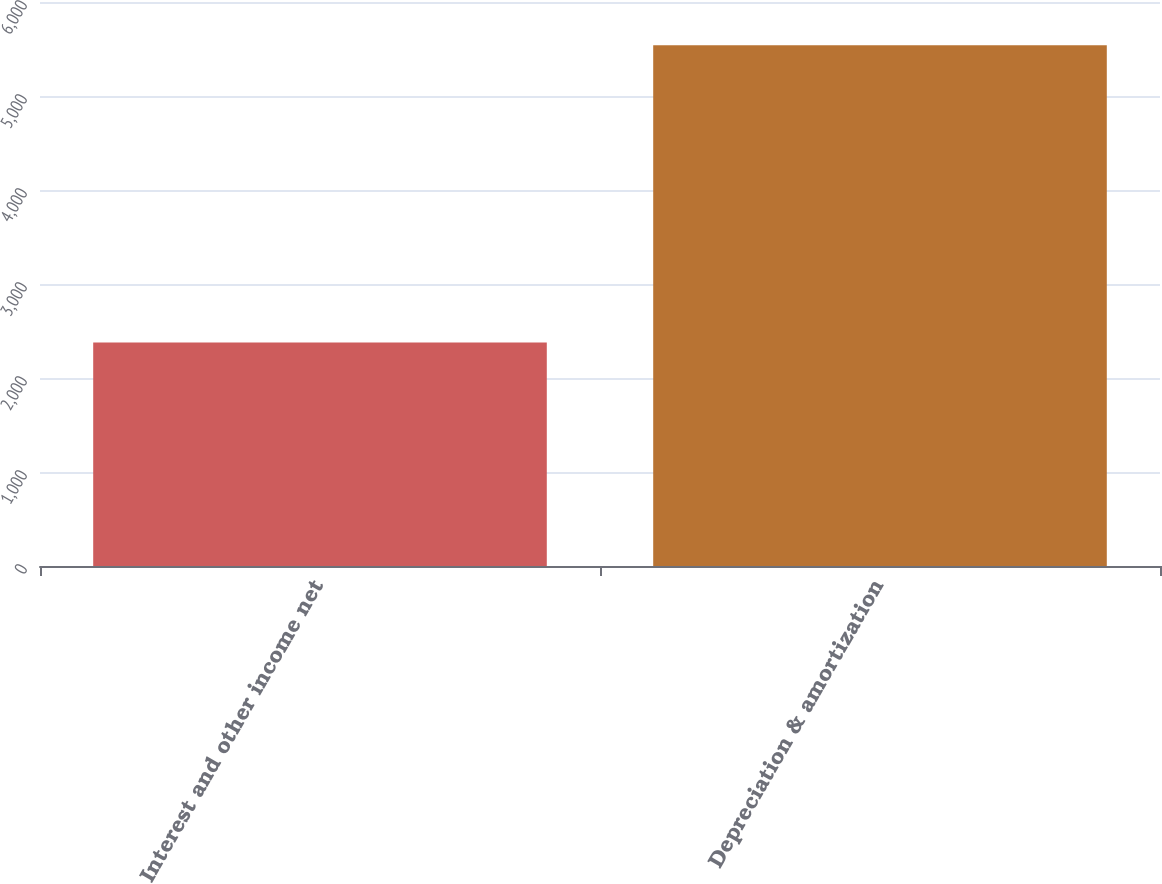<chart> <loc_0><loc_0><loc_500><loc_500><bar_chart><fcel>Interest and other income net<fcel>Depreciation & amortization<nl><fcel>2378<fcel>5540<nl></chart> 